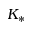Convert formula to latex. <formula><loc_0><loc_0><loc_500><loc_500>K _ { * }</formula> 